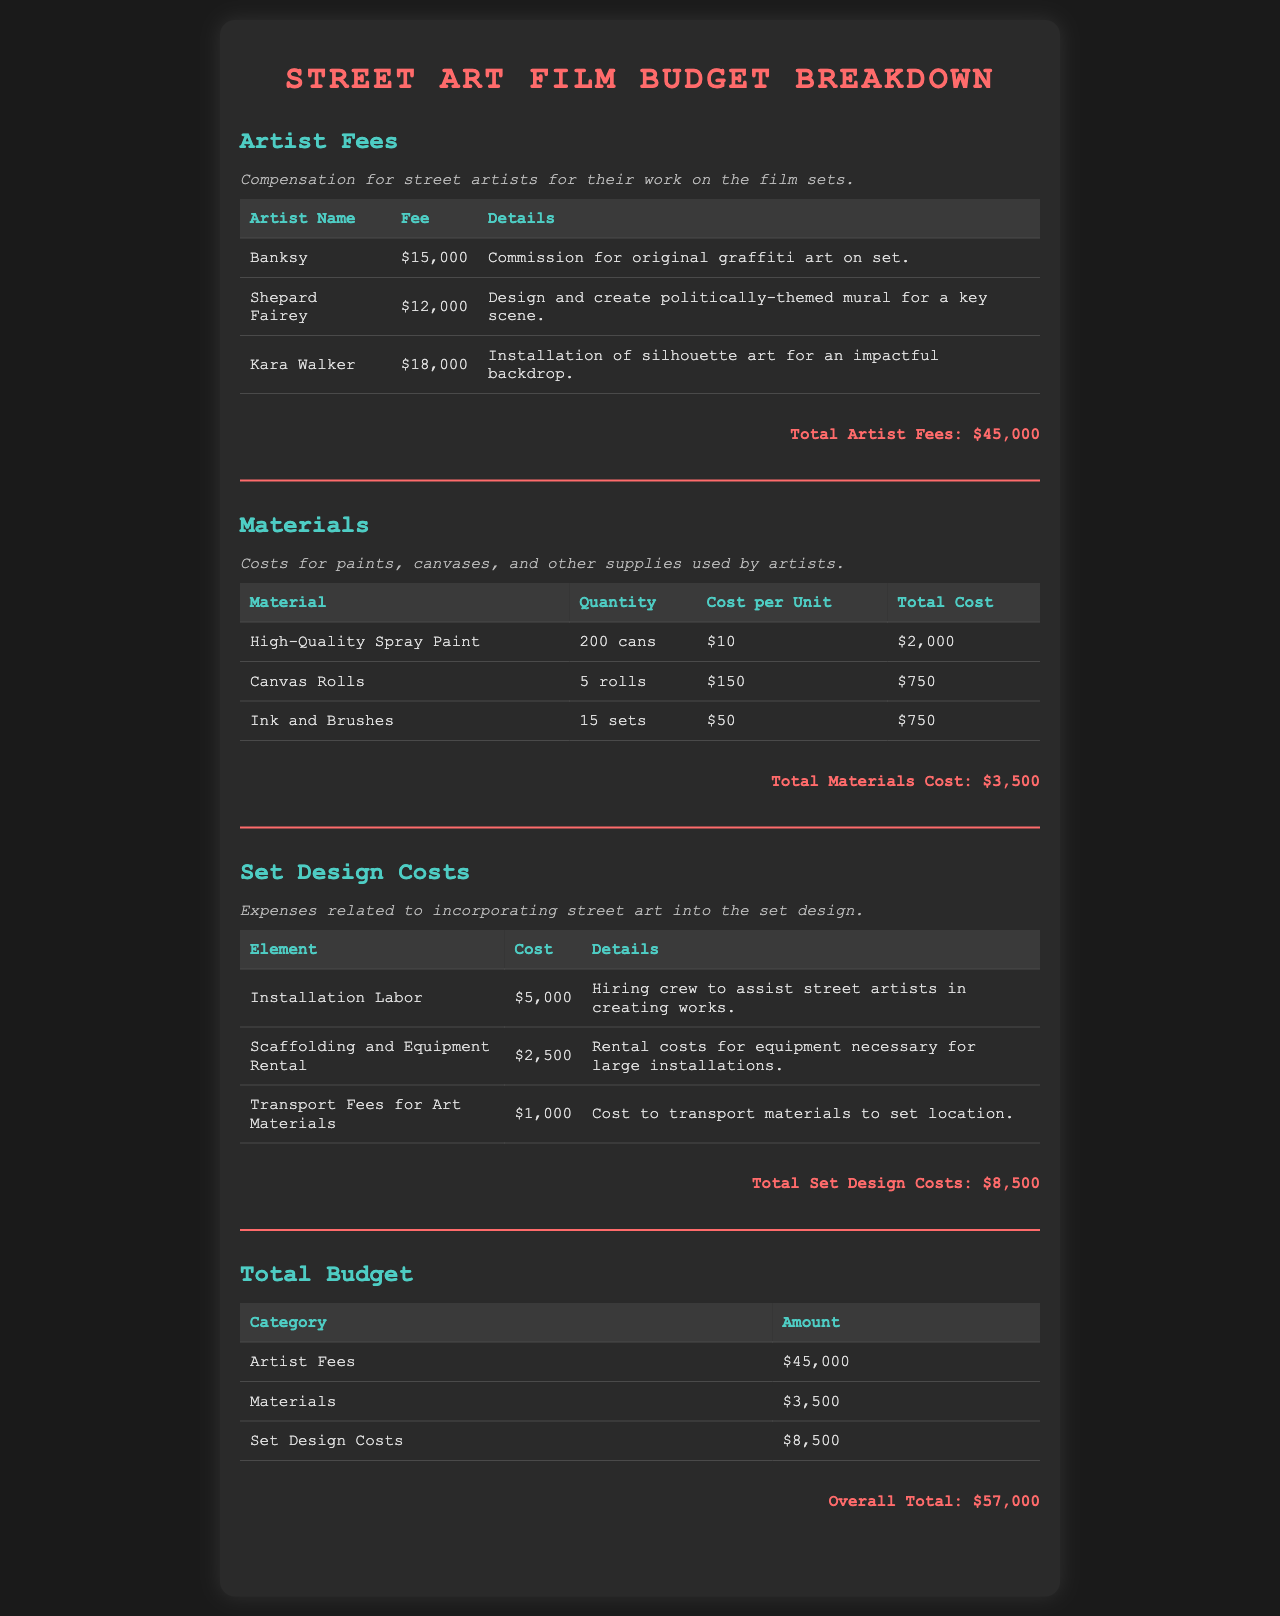What is the total amount for artist fees? The total amount for artist fees is the sum of individual fees listed for each artist, which is $15,000 + $12,000 + $18,000 = $45,000.
Answer: $45,000 What is the cost of high-quality spray paint? The cost of high-quality spray paint is specified as $10 per can and the quantity is 200 cans, resulting in a total of $2,000.
Answer: $2,000 Who is responsible for the politically-themed mural? Shepard Fairey is the artist responsible for designing and creating the politically-themed mural for a key scene in the film.
Answer: Shepard Fairey What is the total cost for materials? The total cost for materials is calculated by summing up the individual costs of all materials listed, which totals to $3,500.
Answer: $3,500 What is included in the set design costs? Set design costs include expenses for installation labor, scaffolding rental, and transport fees for art materials, as detailed in the document.
Answer: Installation Labor, Scaffolding and Equipment Rental, Transport Fees for Art Materials What is the overall total budget for the project? The overall total budget is the cumulative total of artist fees, materials, and set design costs, which equals $57,000.
Answer: $57,000 How much is spent on installation labor? The document specifies that the cost for installation labor is $5,000.
Answer: $5,000 How many sets of ink and brushes are included in the materials? The document lists a total of 15 sets of ink and brushes as part of the materials costs.
Answer: 15 sets What is the cost of transport fees for art materials? The document indicates that the cost for transport fees for art materials is $1,000.
Answer: $1,000 